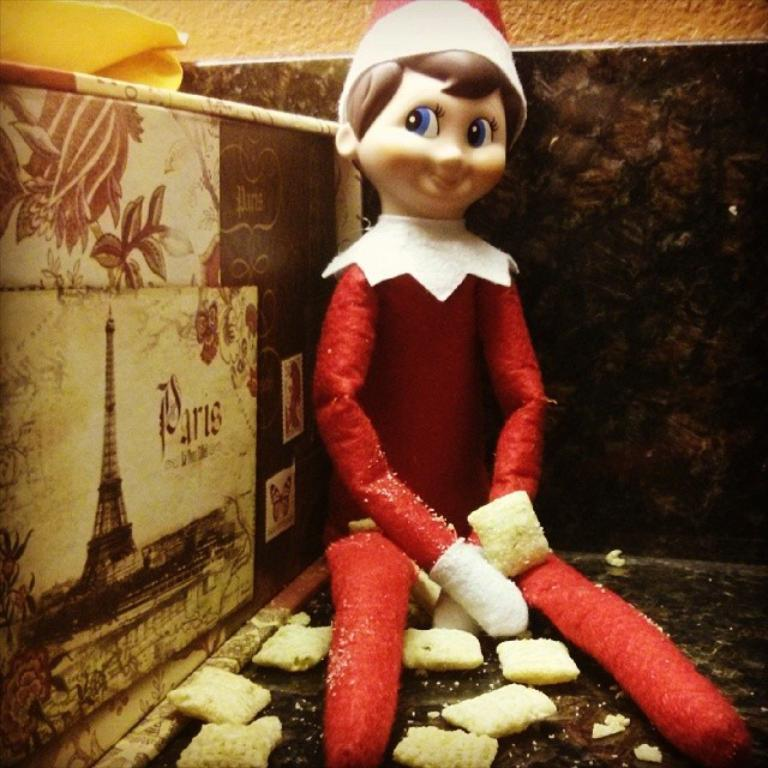What is the main object in the image? There is a toy in the image. What is the expression of the toy? The toy is smiling. What can be seen on the floor in the image? There are objects on the floor in the image. What is on the wall in the image? There is a painting on the wall in the image. What is visible in the background of the image? There is a wall visible in the background of the image. What type of growth is the tramp experiencing in the image? There is no tramp or growth present in the image; it features a toy with a smiling expression. 